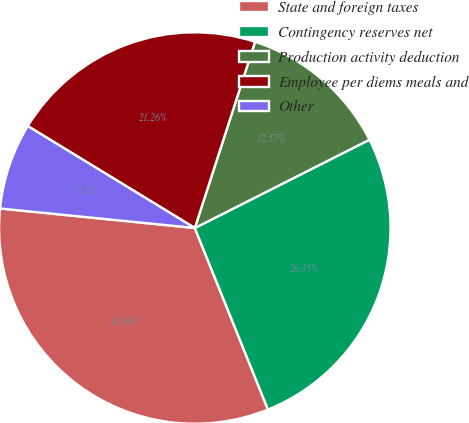Convert chart. <chart><loc_0><loc_0><loc_500><loc_500><pie_chart><fcel>State and foreign taxes<fcel>Contingency reserves net<fcel>Production activity deduction<fcel>Employee per diems meals and<fcel>Other<nl><fcel>32.69%<fcel>26.35%<fcel>12.57%<fcel>21.26%<fcel>7.13%<nl></chart> 